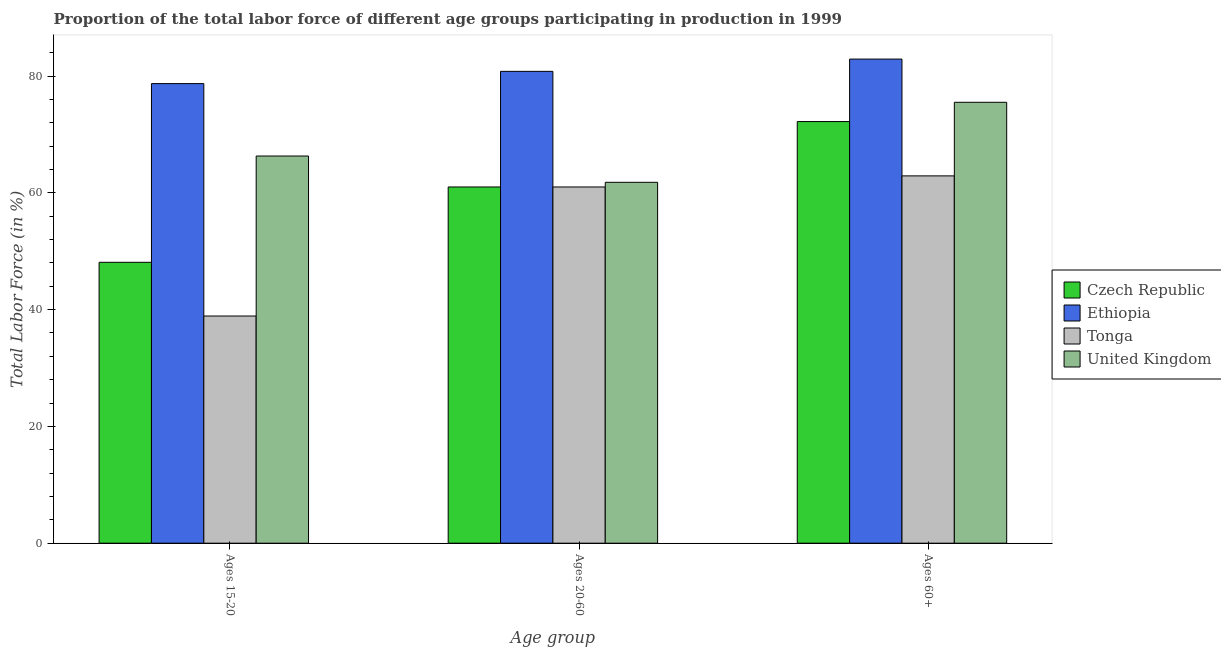Are the number of bars per tick equal to the number of legend labels?
Your answer should be compact. Yes. Are the number of bars on each tick of the X-axis equal?
Your answer should be very brief. Yes. How many bars are there on the 1st tick from the left?
Your answer should be very brief. 4. What is the label of the 3rd group of bars from the left?
Ensure brevity in your answer.  Ages 60+. What is the percentage of labor force above age 60 in Tonga?
Offer a very short reply. 62.9. Across all countries, what is the maximum percentage of labor force within the age group 20-60?
Offer a very short reply. 80.8. Across all countries, what is the minimum percentage of labor force above age 60?
Your answer should be compact. 62.9. In which country was the percentage of labor force within the age group 20-60 maximum?
Offer a very short reply. Ethiopia. In which country was the percentage of labor force above age 60 minimum?
Offer a very short reply. Tonga. What is the total percentage of labor force above age 60 in the graph?
Provide a short and direct response. 293.5. What is the difference between the percentage of labor force above age 60 in Ethiopia and that in Tonga?
Your answer should be very brief. 20. What is the difference between the percentage of labor force within the age group 20-60 in United Kingdom and the percentage of labor force within the age group 15-20 in Ethiopia?
Make the answer very short. -16.9. What is the average percentage of labor force above age 60 per country?
Provide a short and direct response. 73.38. What is the difference between the percentage of labor force within the age group 20-60 and percentage of labor force within the age group 15-20 in United Kingdom?
Your answer should be very brief. -4.5. What is the ratio of the percentage of labor force within the age group 20-60 in Czech Republic to that in Tonga?
Provide a short and direct response. 1. Is the percentage of labor force within the age group 15-20 in Ethiopia less than that in United Kingdom?
Make the answer very short. No. Is the difference between the percentage of labor force within the age group 15-20 in United Kingdom and Tonga greater than the difference between the percentage of labor force above age 60 in United Kingdom and Tonga?
Your response must be concise. Yes. What is the difference between the highest and the second highest percentage of labor force within the age group 15-20?
Provide a short and direct response. 12.4. What is the difference between the highest and the lowest percentage of labor force within the age group 15-20?
Your answer should be compact. 39.8. In how many countries, is the percentage of labor force within the age group 20-60 greater than the average percentage of labor force within the age group 20-60 taken over all countries?
Offer a very short reply. 1. Is the sum of the percentage of labor force within the age group 15-20 in Ethiopia and United Kingdom greater than the maximum percentage of labor force above age 60 across all countries?
Ensure brevity in your answer.  Yes. What does the 2nd bar from the left in Ages 60+ represents?
Offer a very short reply. Ethiopia. What does the 1st bar from the right in Ages 15-20 represents?
Your answer should be very brief. United Kingdom. How many countries are there in the graph?
Your answer should be very brief. 4. Are the values on the major ticks of Y-axis written in scientific E-notation?
Make the answer very short. No. Where does the legend appear in the graph?
Your response must be concise. Center right. How many legend labels are there?
Keep it short and to the point. 4. How are the legend labels stacked?
Provide a short and direct response. Vertical. What is the title of the graph?
Your answer should be very brief. Proportion of the total labor force of different age groups participating in production in 1999. What is the label or title of the X-axis?
Make the answer very short. Age group. What is the label or title of the Y-axis?
Keep it short and to the point. Total Labor Force (in %). What is the Total Labor Force (in %) in Czech Republic in Ages 15-20?
Provide a succinct answer. 48.1. What is the Total Labor Force (in %) in Ethiopia in Ages 15-20?
Give a very brief answer. 78.7. What is the Total Labor Force (in %) in Tonga in Ages 15-20?
Keep it short and to the point. 38.9. What is the Total Labor Force (in %) of United Kingdom in Ages 15-20?
Your answer should be compact. 66.3. What is the Total Labor Force (in %) of Ethiopia in Ages 20-60?
Offer a terse response. 80.8. What is the Total Labor Force (in %) of Tonga in Ages 20-60?
Make the answer very short. 61. What is the Total Labor Force (in %) in United Kingdom in Ages 20-60?
Keep it short and to the point. 61.8. What is the Total Labor Force (in %) of Czech Republic in Ages 60+?
Offer a very short reply. 72.2. What is the Total Labor Force (in %) of Ethiopia in Ages 60+?
Make the answer very short. 82.9. What is the Total Labor Force (in %) in Tonga in Ages 60+?
Make the answer very short. 62.9. What is the Total Labor Force (in %) in United Kingdom in Ages 60+?
Your response must be concise. 75.5. Across all Age group, what is the maximum Total Labor Force (in %) of Czech Republic?
Provide a succinct answer. 72.2. Across all Age group, what is the maximum Total Labor Force (in %) in Ethiopia?
Provide a short and direct response. 82.9. Across all Age group, what is the maximum Total Labor Force (in %) in Tonga?
Keep it short and to the point. 62.9. Across all Age group, what is the maximum Total Labor Force (in %) in United Kingdom?
Keep it short and to the point. 75.5. Across all Age group, what is the minimum Total Labor Force (in %) in Czech Republic?
Ensure brevity in your answer.  48.1. Across all Age group, what is the minimum Total Labor Force (in %) of Ethiopia?
Keep it short and to the point. 78.7. Across all Age group, what is the minimum Total Labor Force (in %) of Tonga?
Make the answer very short. 38.9. Across all Age group, what is the minimum Total Labor Force (in %) in United Kingdom?
Your answer should be very brief. 61.8. What is the total Total Labor Force (in %) of Czech Republic in the graph?
Your answer should be very brief. 181.3. What is the total Total Labor Force (in %) in Ethiopia in the graph?
Keep it short and to the point. 242.4. What is the total Total Labor Force (in %) of Tonga in the graph?
Offer a terse response. 162.8. What is the total Total Labor Force (in %) in United Kingdom in the graph?
Offer a terse response. 203.6. What is the difference between the Total Labor Force (in %) of Czech Republic in Ages 15-20 and that in Ages 20-60?
Offer a terse response. -12.9. What is the difference between the Total Labor Force (in %) of Ethiopia in Ages 15-20 and that in Ages 20-60?
Keep it short and to the point. -2.1. What is the difference between the Total Labor Force (in %) of Tonga in Ages 15-20 and that in Ages 20-60?
Your answer should be very brief. -22.1. What is the difference between the Total Labor Force (in %) of Czech Republic in Ages 15-20 and that in Ages 60+?
Ensure brevity in your answer.  -24.1. What is the difference between the Total Labor Force (in %) of Ethiopia in Ages 15-20 and that in Ages 60+?
Make the answer very short. -4.2. What is the difference between the Total Labor Force (in %) in Tonga in Ages 15-20 and that in Ages 60+?
Keep it short and to the point. -24. What is the difference between the Total Labor Force (in %) of United Kingdom in Ages 15-20 and that in Ages 60+?
Ensure brevity in your answer.  -9.2. What is the difference between the Total Labor Force (in %) in Czech Republic in Ages 20-60 and that in Ages 60+?
Offer a very short reply. -11.2. What is the difference between the Total Labor Force (in %) in United Kingdom in Ages 20-60 and that in Ages 60+?
Your answer should be very brief. -13.7. What is the difference between the Total Labor Force (in %) in Czech Republic in Ages 15-20 and the Total Labor Force (in %) in Ethiopia in Ages 20-60?
Provide a short and direct response. -32.7. What is the difference between the Total Labor Force (in %) of Czech Republic in Ages 15-20 and the Total Labor Force (in %) of United Kingdom in Ages 20-60?
Your response must be concise. -13.7. What is the difference between the Total Labor Force (in %) in Ethiopia in Ages 15-20 and the Total Labor Force (in %) in United Kingdom in Ages 20-60?
Your answer should be compact. 16.9. What is the difference between the Total Labor Force (in %) in Tonga in Ages 15-20 and the Total Labor Force (in %) in United Kingdom in Ages 20-60?
Your answer should be very brief. -22.9. What is the difference between the Total Labor Force (in %) in Czech Republic in Ages 15-20 and the Total Labor Force (in %) in Ethiopia in Ages 60+?
Your answer should be compact. -34.8. What is the difference between the Total Labor Force (in %) in Czech Republic in Ages 15-20 and the Total Labor Force (in %) in Tonga in Ages 60+?
Your answer should be very brief. -14.8. What is the difference between the Total Labor Force (in %) in Czech Republic in Ages 15-20 and the Total Labor Force (in %) in United Kingdom in Ages 60+?
Provide a short and direct response. -27.4. What is the difference between the Total Labor Force (in %) in Ethiopia in Ages 15-20 and the Total Labor Force (in %) in United Kingdom in Ages 60+?
Your response must be concise. 3.2. What is the difference between the Total Labor Force (in %) in Tonga in Ages 15-20 and the Total Labor Force (in %) in United Kingdom in Ages 60+?
Provide a succinct answer. -36.6. What is the difference between the Total Labor Force (in %) in Czech Republic in Ages 20-60 and the Total Labor Force (in %) in Ethiopia in Ages 60+?
Give a very brief answer. -21.9. What is the difference between the Total Labor Force (in %) in Czech Republic in Ages 20-60 and the Total Labor Force (in %) in United Kingdom in Ages 60+?
Give a very brief answer. -14.5. What is the difference between the Total Labor Force (in %) in Ethiopia in Ages 20-60 and the Total Labor Force (in %) in Tonga in Ages 60+?
Offer a very short reply. 17.9. What is the difference between the Total Labor Force (in %) of Tonga in Ages 20-60 and the Total Labor Force (in %) of United Kingdom in Ages 60+?
Offer a very short reply. -14.5. What is the average Total Labor Force (in %) in Czech Republic per Age group?
Ensure brevity in your answer.  60.43. What is the average Total Labor Force (in %) in Ethiopia per Age group?
Provide a succinct answer. 80.8. What is the average Total Labor Force (in %) in Tonga per Age group?
Provide a short and direct response. 54.27. What is the average Total Labor Force (in %) in United Kingdom per Age group?
Make the answer very short. 67.87. What is the difference between the Total Labor Force (in %) of Czech Republic and Total Labor Force (in %) of Ethiopia in Ages 15-20?
Offer a terse response. -30.6. What is the difference between the Total Labor Force (in %) of Czech Republic and Total Labor Force (in %) of United Kingdom in Ages 15-20?
Your answer should be compact. -18.2. What is the difference between the Total Labor Force (in %) in Ethiopia and Total Labor Force (in %) in Tonga in Ages 15-20?
Your answer should be very brief. 39.8. What is the difference between the Total Labor Force (in %) of Tonga and Total Labor Force (in %) of United Kingdom in Ages 15-20?
Your response must be concise. -27.4. What is the difference between the Total Labor Force (in %) of Czech Republic and Total Labor Force (in %) of Ethiopia in Ages 20-60?
Provide a succinct answer. -19.8. What is the difference between the Total Labor Force (in %) in Ethiopia and Total Labor Force (in %) in Tonga in Ages 20-60?
Provide a short and direct response. 19.8. What is the difference between the Total Labor Force (in %) of Ethiopia and Total Labor Force (in %) of United Kingdom in Ages 60+?
Your answer should be very brief. 7.4. What is the difference between the Total Labor Force (in %) of Tonga and Total Labor Force (in %) of United Kingdom in Ages 60+?
Your answer should be very brief. -12.6. What is the ratio of the Total Labor Force (in %) in Czech Republic in Ages 15-20 to that in Ages 20-60?
Your answer should be very brief. 0.79. What is the ratio of the Total Labor Force (in %) of Ethiopia in Ages 15-20 to that in Ages 20-60?
Your answer should be compact. 0.97. What is the ratio of the Total Labor Force (in %) of Tonga in Ages 15-20 to that in Ages 20-60?
Your answer should be compact. 0.64. What is the ratio of the Total Labor Force (in %) of United Kingdom in Ages 15-20 to that in Ages 20-60?
Make the answer very short. 1.07. What is the ratio of the Total Labor Force (in %) in Czech Republic in Ages 15-20 to that in Ages 60+?
Provide a succinct answer. 0.67. What is the ratio of the Total Labor Force (in %) in Ethiopia in Ages 15-20 to that in Ages 60+?
Offer a terse response. 0.95. What is the ratio of the Total Labor Force (in %) of Tonga in Ages 15-20 to that in Ages 60+?
Provide a succinct answer. 0.62. What is the ratio of the Total Labor Force (in %) of United Kingdom in Ages 15-20 to that in Ages 60+?
Your answer should be very brief. 0.88. What is the ratio of the Total Labor Force (in %) of Czech Republic in Ages 20-60 to that in Ages 60+?
Your answer should be compact. 0.84. What is the ratio of the Total Labor Force (in %) in Ethiopia in Ages 20-60 to that in Ages 60+?
Ensure brevity in your answer.  0.97. What is the ratio of the Total Labor Force (in %) of Tonga in Ages 20-60 to that in Ages 60+?
Offer a terse response. 0.97. What is the ratio of the Total Labor Force (in %) in United Kingdom in Ages 20-60 to that in Ages 60+?
Ensure brevity in your answer.  0.82. What is the difference between the highest and the second highest Total Labor Force (in %) of Czech Republic?
Provide a succinct answer. 11.2. What is the difference between the highest and the second highest Total Labor Force (in %) of Ethiopia?
Give a very brief answer. 2.1. What is the difference between the highest and the lowest Total Labor Force (in %) in Czech Republic?
Make the answer very short. 24.1. What is the difference between the highest and the lowest Total Labor Force (in %) of Tonga?
Offer a very short reply. 24. What is the difference between the highest and the lowest Total Labor Force (in %) in United Kingdom?
Ensure brevity in your answer.  13.7. 